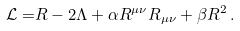<formula> <loc_0><loc_0><loc_500><loc_500>\mathcal { L = } R - 2 \Lambda + \alpha R ^ { \mu \nu } R _ { \mu \nu } + \beta R ^ { 2 } \, .</formula> 